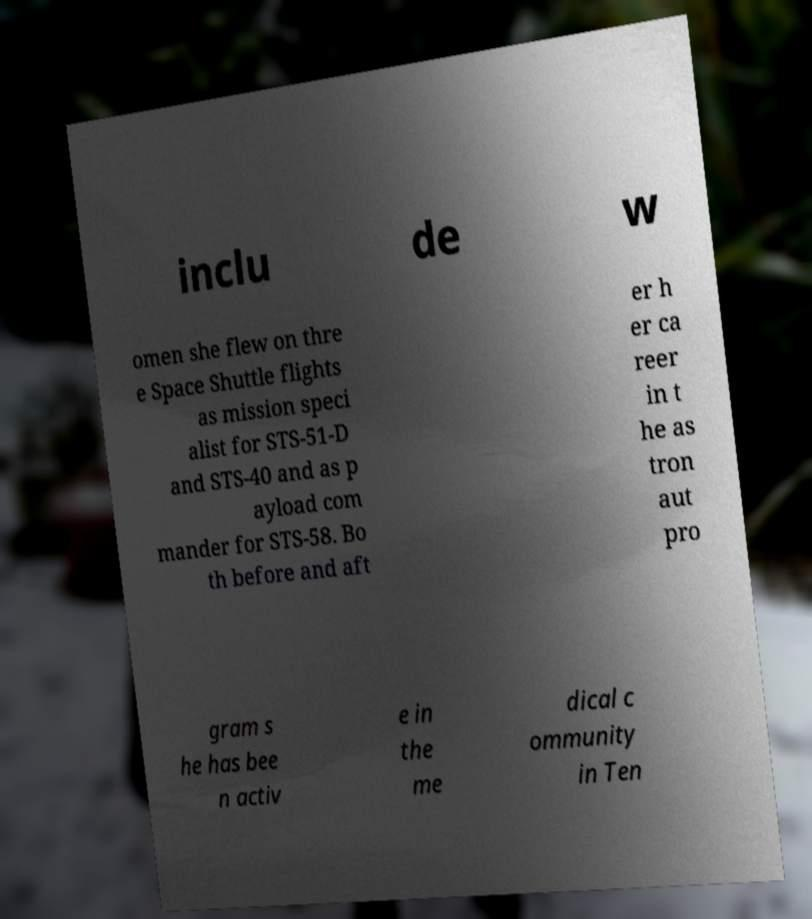Could you assist in decoding the text presented in this image and type it out clearly? inclu de w omen she flew on thre e Space Shuttle flights as mission speci alist for STS-51-D and STS-40 and as p ayload com mander for STS-58. Bo th before and aft er h er ca reer in t he as tron aut pro gram s he has bee n activ e in the me dical c ommunity in Ten 